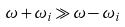Convert formula to latex. <formula><loc_0><loc_0><loc_500><loc_500>\omega + \omega _ { i } \gg \omega - \omega _ { i }</formula> 